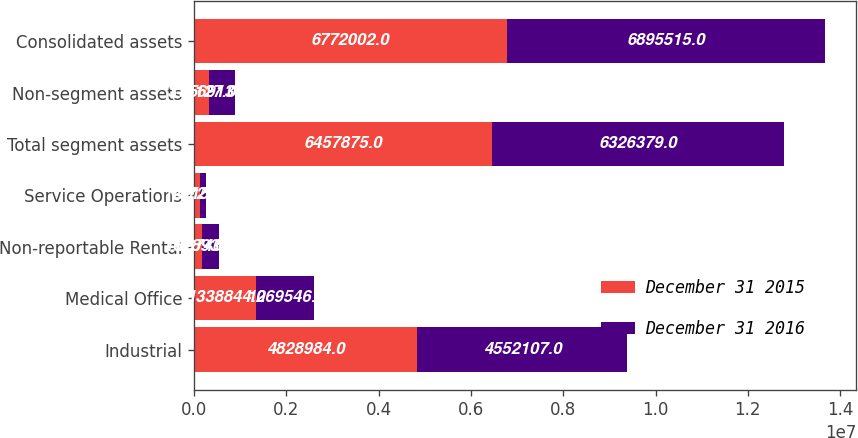<chart> <loc_0><loc_0><loc_500><loc_500><stacked_bar_chart><ecel><fcel>Industrial<fcel>Medical Office<fcel>Non-reportable Rental<fcel>Service Operations<fcel>Total segment assets<fcel>Non-segment assets<fcel>Consolidated assets<nl><fcel>December 31 2015<fcel>4.82898e+06<fcel>1.33884e+06<fcel>162893<fcel>127154<fcel>6.45788e+06<fcel>314127<fcel>6.772e+06<nl><fcel>December 31 2016<fcel>4.55211e+06<fcel>1.26955e+06<fcel>367469<fcel>137257<fcel>6.32638e+06<fcel>569136<fcel>6.89552e+06<nl></chart> 